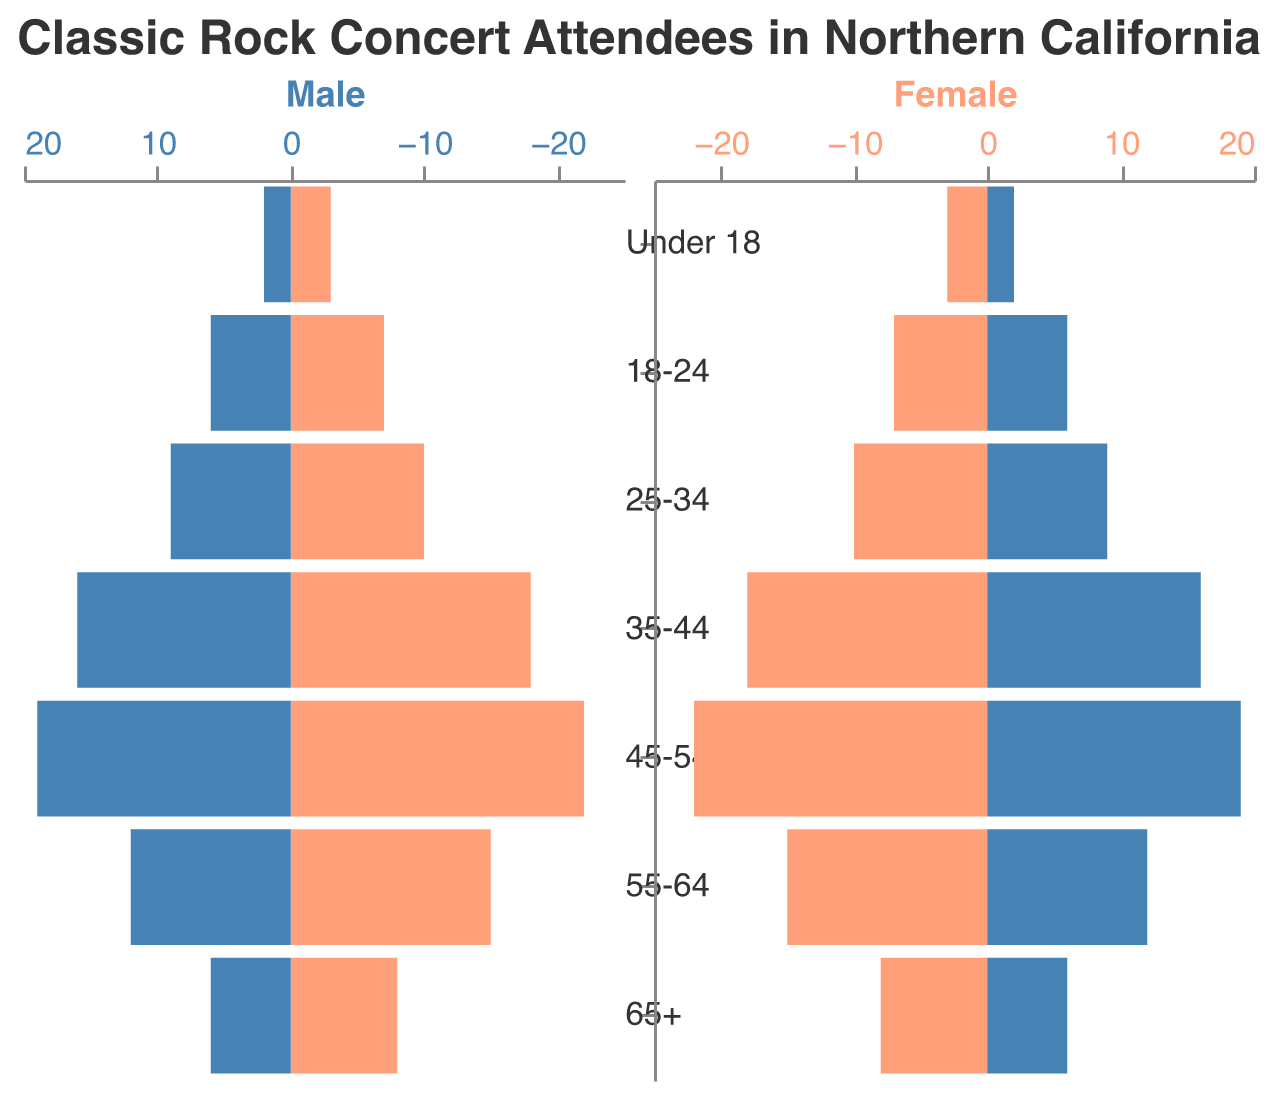What is the title of the figure? The title of the figure is displayed at the top. It reads "Classic Rock Concert Attendees in Northern California."
Answer: Classic Rock Concert Attendees in Northern California Which age group has the highest number of female attendees? By looking at the female side of the pyramid, you can see that the 45-54 age group has the highest bar.
Answer: 45-54 What is the number of male attendees in the 25-34 age group? On the male side of the pyramid, the bar for the 25-34 age group is labeled with a value of 10.
Answer: 10 How many more male attendees are there in the 45-54 age group compared to the 55-64 age group? The number of male attendees in the 45-54 age group is 22, and in the 55-64 age group, it is 15. The difference is 22 - 15 = 7.
Answer: 7 What is the total number of attendees in the age group 18-24? Adding the number of male attendees (7) and female attendees (6) in the 18-24 age group, we get 7 + 6 = 13.
Answer: 13 Which age group has the lowest number of total attendees? The age group with the smallest bars on both sides is "Under 18." Adding both male and female attendees (3 + 2), we have a total of 5 attendees.
Answer: Under 18 Compare the number of female attendees in the 55-64 age group with the 65+ age group. Which one is higher? The number of female attendees in the 55-64 age group is 12, and in the 65+ age group, it is 6. The 55-64 age group has more female attendees.
Answer: 55-64 What is the ratio of female to male attendees in the 35-44 age group? The number of female attendees in the 35-44 age group is 16, and the number of males is 18. The ratio is 16:18, which simplifies to 8:9.
Answer: 8:9 How does the gender distribution compare between the 45-54 and 35-44 age groups? The 45-54 age group has 22 males and 19 females, and the 35-44 age group has 18 males and 16 females. Both groups have more males than females, but the difference is greater in the 45-54 age group (22-19 = 3) than in the 35-44 age group (18-16 = 2).
Answer: 45-54 has a higher male-to-female difference 